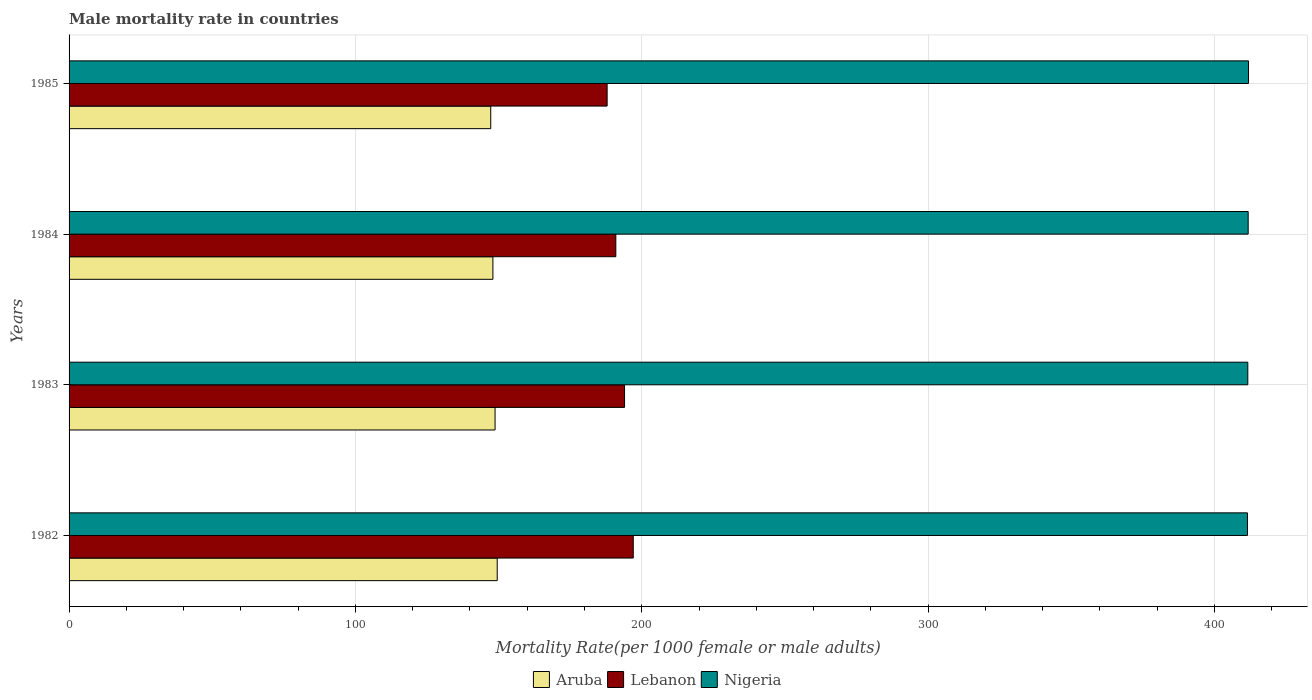How many different coloured bars are there?
Your answer should be compact. 3. Are the number of bars per tick equal to the number of legend labels?
Offer a terse response. Yes. How many bars are there on the 4th tick from the top?
Offer a terse response. 3. What is the label of the 2nd group of bars from the top?
Offer a terse response. 1984. In how many cases, is the number of bars for a given year not equal to the number of legend labels?
Provide a short and direct response. 0. What is the male mortality rate in Nigeria in 1983?
Provide a succinct answer. 411.62. Across all years, what is the maximum male mortality rate in Aruba?
Keep it short and to the point. 149.51. Across all years, what is the minimum male mortality rate in Aruba?
Ensure brevity in your answer.  147.25. In which year was the male mortality rate in Aruba maximum?
Offer a very short reply. 1982. What is the total male mortality rate in Lebanon in the graph?
Provide a short and direct response. 769.82. What is the difference between the male mortality rate in Lebanon in 1984 and that in 1985?
Offer a very short reply. 3.04. What is the difference between the male mortality rate in Lebanon in 1983 and the male mortality rate in Nigeria in 1982?
Your response must be concise. -217.52. What is the average male mortality rate in Lebanon per year?
Your answer should be very brief. 192.46. In the year 1983, what is the difference between the male mortality rate in Lebanon and male mortality rate in Nigeria?
Your response must be concise. -217.65. What is the ratio of the male mortality rate in Nigeria in 1982 to that in 1983?
Your answer should be very brief. 1. Is the male mortality rate in Nigeria in 1983 less than that in 1985?
Your answer should be very brief. Yes. Is the difference between the male mortality rate in Lebanon in 1982 and 1984 greater than the difference between the male mortality rate in Nigeria in 1982 and 1984?
Offer a very short reply. Yes. What is the difference between the highest and the second highest male mortality rate in Lebanon?
Your answer should be very brief. 3.04. What is the difference between the highest and the lowest male mortality rate in Lebanon?
Give a very brief answer. 9.13. Is the sum of the male mortality rate in Lebanon in 1982 and 1985 greater than the maximum male mortality rate in Nigeria across all years?
Ensure brevity in your answer.  No. What does the 1st bar from the top in 1985 represents?
Your answer should be compact. Nigeria. What does the 2nd bar from the bottom in 1985 represents?
Your answer should be very brief. Lebanon. Is it the case that in every year, the sum of the male mortality rate in Aruba and male mortality rate in Nigeria is greater than the male mortality rate in Lebanon?
Keep it short and to the point. Yes. How many bars are there?
Your response must be concise. 12. How many years are there in the graph?
Your answer should be compact. 4. What is the difference between two consecutive major ticks on the X-axis?
Your answer should be very brief. 100. Are the values on the major ticks of X-axis written in scientific E-notation?
Give a very brief answer. No. How are the legend labels stacked?
Provide a succinct answer. Horizontal. What is the title of the graph?
Your answer should be compact. Male mortality rate in countries. Does "Other small states" appear as one of the legend labels in the graph?
Provide a succinct answer. No. What is the label or title of the X-axis?
Provide a short and direct response. Mortality Rate(per 1000 female or male adults). What is the Mortality Rate(per 1000 female or male adults) of Aruba in 1982?
Keep it short and to the point. 149.51. What is the Mortality Rate(per 1000 female or male adults) of Lebanon in 1982?
Provide a succinct answer. 197.02. What is the Mortality Rate(per 1000 female or male adults) in Nigeria in 1982?
Offer a terse response. 411.5. What is the Mortality Rate(per 1000 female or male adults) of Aruba in 1983?
Provide a succinct answer. 148.76. What is the Mortality Rate(per 1000 female or male adults) of Lebanon in 1983?
Your response must be concise. 193.98. What is the Mortality Rate(per 1000 female or male adults) in Nigeria in 1983?
Offer a very short reply. 411.62. What is the Mortality Rate(per 1000 female or male adults) of Aruba in 1984?
Keep it short and to the point. 148. What is the Mortality Rate(per 1000 female or male adults) of Lebanon in 1984?
Your response must be concise. 190.93. What is the Mortality Rate(per 1000 female or male adults) of Nigeria in 1984?
Provide a succinct answer. 411.75. What is the Mortality Rate(per 1000 female or male adults) in Aruba in 1985?
Give a very brief answer. 147.25. What is the Mortality Rate(per 1000 female or male adults) in Lebanon in 1985?
Provide a succinct answer. 187.89. What is the Mortality Rate(per 1000 female or male adults) in Nigeria in 1985?
Ensure brevity in your answer.  411.87. Across all years, what is the maximum Mortality Rate(per 1000 female or male adults) in Aruba?
Your answer should be compact. 149.51. Across all years, what is the maximum Mortality Rate(per 1000 female or male adults) of Lebanon?
Ensure brevity in your answer.  197.02. Across all years, what is the maximum Mortality Rate(per 1000 female or male adults) of Nigeria?
Provide a succinct answer. 411.87. Across all years, what is the minimum Mortality Rate(per 1000 female or male adults) of Aruba?
Your response must be concise. 147.25. Across all years, what is the minimum Mortality Rate(per 1000 female or male adults) in Lebanon?
Give a very brief answer. 187.89. Across all years, what is the minimum Mortality Rate(per 1000 female or male adults) of Nigeria?
Provide a short and direct response. 411.5. What is the total Mortality Rate(per 1000 female or male adults) of Aruba in the graph?
Offer a terse response. 593.53. What is the total Mortality Rate(per 1000 female or male adults) of Lebanon in the graph?
Offer a terse response. 769.82. What is the total Mortality Rate(per 1000 female or male adults) of Nigeria in the graph?
Keep it short and to the point. 1646.74. What is the difference between the Mortality Rate(per 1000 female or male adults) in Aruba in 1982 and that in 1983?
Give a very brief answer. 0.75. What is the difference between the Mortality Rate(per 1000 female or male adults) in Lebanon in 1982 and that in 1983?
Provide a short and direct response. 3.04. What is the difference between the Mortality Rate(per 1000 female or male adults) in Nigeria in 1982 and that in 1983?
Your answer should be very brief. -0.12. What is the difference between the Mortality Rate(per 1000 female or male adults) in Aruba in 1982 and that in 1984?
Make the answer very short. 1.51. What is the difference between the Mortality Rate(per 1000 female or male adults) in Lebanon in 1982 and that in 1984?
Your response must be concise. 6.09. What is the difference between the Mortality Rate(per 1000 female or male adults) of Nigeria in 1982 and that in 1984?
Provide a succinct answer. -0.25. What is the difference between the Mortality Rate(per 1000 female or male adults) in Aruba in 1982 and that in 1985?
Keep it short and to the point. 2.26. What is the difference between the Mortality Rate(per 1000 female or male adults) of Lebanon in 1982 and that in 1985?
Keep it short and to the point. 9.13. What is the difference between the Mortality Rate(per 1000 female or male adults) of Nigeria in 1982 and that in 1985?
Provide a succinct answer. -0.37. What is the difference between the Mortality Rate(per 1000 female or male adults) of Aruba in 1983 and that in 1984?
Make the answer very short. 0.76. What is the difference between the Mortality Rate(per 1000 female or male adults) in Lebanon in 1983 and that in 1984?
Your response must be concise. 3.04. What is the difference between the Mortality Rate(per 1000 female or male adults) of Nigeria in 1983 and that in 1984?
Ensure brevity in your answer.  -0.12. What is the difference between the Mortality Rate(per 1000 female or male adults) in Aruba in 1983 and that in 1985?
Your answer should be compact. 1.51. What is the difference between the Mortality Rate(per 1000 female or male adults) in Lebanon in 1983 and that in 1985?
Offer a very short reply. 6.09. What is the difference between the Mortality Rate(per 1000 female or male adults) of Nigeria in 1983 and that in 1985?
Your response must be concise. -0.25. What is the difference between the Mortality Rate(per 1000 female or male adults) in Aruba in 1984 and that in 1985?
Make the answer very short. 0.76. What is the difference between the Mortality Rate(per 1000 female or male adults) of Lebanon in 1984 and that in 1985?
Give a very brief answer. 3.04. What is the difference between the Mortality Rate(per 1000 female or male adults) of Nigeria in 1984 and that in 1985?
Ensure brevity in your answer.  -0.12. What is the difference between the Mortality Rate(per 1000 female or male adults) of Aruba in 1982 and the Mortality Rate(per 1000 female or male adults) of Lebanon in 1983?
Your response must be concise. -44.46. What is the difference between the Mortality Rate(per 1000 female or male adults) of Aruba in 1982 and the Mortality Rate(per 1000 female or male adults) of Nigeria in 1983?
Provide a succinct answer. -262.11. What is the difference between the Mortality Rate(per 1000 female or male adults) in Lebanon in 1982 and the Mortality Rate(per 1000 female or male adults) in Nigeria in 1983?
Offer a very short reply. -214.6. What is the difference between the Mortality Rate(per 1000 female or male adults) of Aruba in 1982 and the Mortality Rate(per 1000 female or male adults) of Lebanon in 1984?
Provide a short and direct response. -41.42. What is the difference between the Mortality Rate(per 1000 female or male adults) in Aruba in 1982 and the Mortality Rate(per 1000 female or male adults) in Nigeria in 1984?
Provide a succinct answer. -262.24. What is the difference between the Mortality Rate(per 1000 female or male adults) of Lebanon in 1982 and the Mortality Rate(per 1000 female or male adults) of Nigeria in 1984?
Ensure brevity in your answer.  -214.73. What is the difference between the Mortality Rate(per 1000 female or male adults) of Aruba in 1982 and the Mortality Rate(per 1000 female or male adults) of Lebanon in 1985?
Keep it short and to the point. -38.38. What is the difference between the Mortality Rate(per 1000 female or male adults) in Aruba in 1982 and the Mortality Rate(per 1000 female or male adults) in Nigeria in 1985?
Offer a terse response. -262.36. What is the difference between the Mortality Rate(per 1000 female or male adults) in Lebanon in 1982 and the Mortality Rate(per 1000 female or male adults) in Nigeria in 1985?
Make the answer very short. -214.85. What is the difference between the Mortality Rate(per 1000 female or male adults) of Aruba in 1983 and the Mortality Rate(per 1000 female or male adults) of Lebanon in 1984?
Offer a terse response. -42.17. What is the difference between the Mortality Rate(per 1000 female or male adults) in Aruba in 1983 and the Mortality Rate(per 1000 female or male adults) in Nigeria in 1984?
Give a very brief answer. -262.99. What is the difference between the Mortality Rate(per 1000 female or male adults) in Lebanon in 1983 and the Mortality Rate(per 1000 female or male adults) in Nigeria in 1984?
Your response must be concise. -217.77. What is the difference between the Mortality Rate(per 1000 female or male adults) in Aruba in 1983 and the Mortality Rate(per 1000 female or male adults) in Lebanon in 1985?
Keep it short and to the point. -39.13. What is the difference between the Mortality Rate(per 1000 female or male adults) in Aruba in 1983 and the Mortality Rate(per 1000 female or male adults) in Nigeria in 1985?
Provide a succinct answer. -263.11. What is the difference between the Mortality Rate(per 1000 female or male adults) in Lebanon in 1983 and the Mortality Rate(per 1000 female or male adults) in Nigeria in 1985?
Your answer should be very brief. -217.9. What is the difference between the Mortality Rate(per 1000 female or male adults) in Aruba in 1984 and the Mortality Rate(per 1000 female or male adults) in Lebanon in 1985?
Offer a very short reply. -39.89. What is the difference between the Mortality Rate(per 1000 female or male adults) in Aruba in 1984 and the Mortality Rate(per 1000 female or male adults) in Nigeria in 1985?
Your answer should be compact. -263.87. What is the difference between the Mortality Rate(per 1000 female or male adults) in Lebanon in 1984 and the Mortality Rate(per 1000 female or male adults) in Nigeria in 1985?
Provide a succinct answer. -220.94. What is the average Mortality Rate(per 1000 female or male adults) in Aruba per year?
Your response must be concise. 148.38. What is the average Mortality Rate(per 1000 female or male adults) of Lebanon per year?
Give a very brief answer. 192.46. What is the average Mortality Rate(per 1000 female or male adults) of Nigeria per year?
Give a very brief answer. 411.69. In the year 1982, what is the difference between the Mortality Rate(per 1000 female or male adults) in Aruba and Mortality Rate(per 1000 female or male adults) in Lebanon?
Ensure brevity in your answer.  -47.51. In the year 1982, what is the difference between the Mortality Rate(per 1000 female or male adults) of Aruba and Mortality Rate(per 1000 female or male adults) of Nigeria?
Make the answer very short. -261.99. In the year 1982, what is the difference between the Mortality Rate(per 1000 female or male adults) in Lebanon and Mortality Rate(per 1000 female or male adults) in Nigeria?
Make the answer very short. -214.48. In the year 1983, what is the difference between the Mortality Rate(per 1000 female or male adults) of Aruba and Mortality Rate(per 1000 female or male adults) of Lebanon?
Your answer should be very brief. -45.22. In the year 1983, what is the difference between the Mortality Rate(per 1000 female or male adults) in Aruba and Mortality Rate(per 1000 female or male adults) in Nigeria?
Your answer should be very brief. -262.86. In the year 1983, what is the difference between the Mortality Rate(per 1000 female or male adults) of Lebanon and Mortality Rate(per 1000 female or male adults) of Nigeria?
Provide a succinct answer. -217.65. In the year 1984, what is the difference between the Mortality Rate(per 1000 female or male adults) in Aruba and Mortality Rate(per 1000 female or male adults) in Lebanon?
Your answer should be very brief. -42.93. In the year 1984, what is the difference between the Mortality Rate(per 1000 female or male adults) of Aruba and Mortality Rate(per 1000 female or male adults) of Nigeria?
Give a very brief answer. -263.74. In the year 1984, what is the difference between the Mortality Rate(per 1000 female or male adults) in Lebanon and Mortality Rate(per 1000 female or male adults) in Nigeria?
Provide a short and direct response. -220.81. In the year 1985, what is the difference between the Mortality Rate(per 1000 female or male adults) in Aruba and Mortality Rate(per 1000 female or male adults) in Lebanon?
Make the answer very short. -40.64. In the year 1985, what is the difference between the Mortality Rate(per 1000 female or male adults) of Aruba and Mortality Rate(per 1000 female or male adults) of Nigeria?
Your answer should be very brief. -264.62. In the year 1985, what is the difference between the Mortality Rate(per 1000 female or male adults) in Lebanon and Mortality Rate(per 1000 female or male adults) in Nigeria?
Give a very brief answer. -223.98. What is the ratio of the Mortality Rate(per 1000 female or male adults) in Aruba in 1982 to that in 1983?
Your answer should be very brief. 1.01. What is the ratio of the Mortality Rate(per 1000 female or male adults) of Lebanon in 1982 to that in 1983?
Your answer should be compact. 1.02. What is the ratio of the Mortality Rate(per 1000 female or male adults) of Nigeria in 1982 to that in 1983?
Your response must be concise. 1. What is the ratio of the Mortality Rate(per 1000 female or male adults) of Aruba in 1982 to that in 1984?
Your response must be concise. 1.01. What is the ratio of the Mortality Rate(per 1000 female or male adults) of Lebanon in 1982 to that in 1984?
Your answer should be compact. 1.03. What is the ratio of the Mortality Rate(per 1000 female or male adults) in Aruba in 1982 to that in 1985?
Keep it short and to the point. 1.02. What is the ratio of the Mortality Rate(per 1000 female or male adults) of Lebanon in 1982 to that in 1985?
Keep it short and to the point. 1.05. What is the ratio of the Mortality Rate(per 1000 female or male adults) in Nigeria in 1982 to that in 1985?
Offer a very short reply. 1. What is the ratio of the Mortality Rate(per 1000 female or male adults) of Aruba in 1983 to that in 1984?
Provide a succinct answer. 1.01. What is the ratio of the Mortality Rate(per 1000 female or male adults) in Lebanon in 1983 to that in 1984?
Provide a short and direct response. 1.02. What is the ratio of the Mortality Rate(per 1000 female or male adults) in Nigeria in 1983 to that in 1984?
Give a very brief answer. 1. What is the ratio of the Mortality Rate(per 1000 female or male adults) in Aruba in 1983 to that in 1985?
Offer a very short reply. 1.01. What is the ratio of the Mortality Rate(per 1000 female or male adults) in Lebanon in 1983 to that in 1985?
Your response must be concise. 1.03. What is the ratio of the Mortality Rate(per 1000 female or male adults) in Nigeria in 1983 to that in 1985?
Provide a short and direct response. 1. What is the ratio of the Mortality Rate(per 1000 female or male adults) of Aruba in 1984 to that in 1985?
Provide a short and direct response. 1.01. What is the ratio of the Mortality Rate(per 1000 female or male adults) of Lebanon in 1984 to that in 1985?
Make the answer very short. 1.02. What is the ratio of the Mortality Rate(per 1000 female or male adults) of Nigeria in 1984 to that in 1985?
Provide a short and direct response. 1. What is the difference between the highest and the second highest Mortality Rate(per 1000 female or male adults) in Aruba?
Provide a succinct answer. 0.75. What is the difference between the highest and the second highest Mortality Rate(per 1000 female or male adults) in Lebanon?
Offer a terse response. 3.04. What is the difference between the highest and the second highest Mortality Rate(per 1000 female or male adults) in Nigeria?
Your response must be concise. 0.12. What is the difference between the highest and the lowest Mortality Rate(per 1000 female or male adults) in Aruba?
Your response must be concise. 2.26. What is the difference between the highest and the lowest Mortality Rate(per 1000 female or male adults) in Lebanon?
Keep it short and to the point. 9.13. What is the difference between the highest and the lowest Mortality Rate(per 1000 female or male adults) of Nigeria?
Provide a short and direct response. 0.37. 